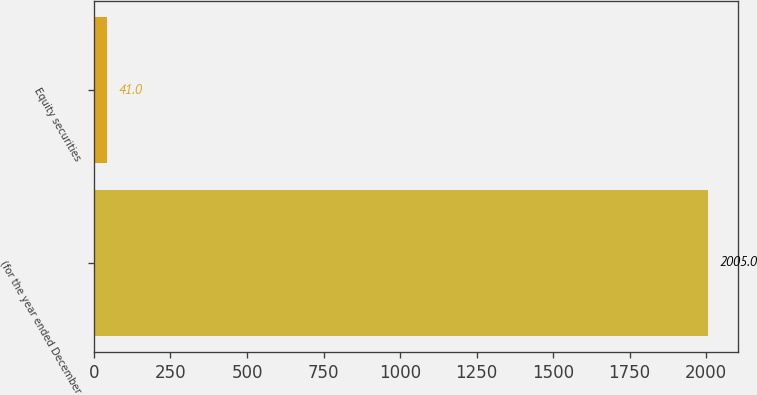Convert chart. <chart><loc_0><loc_0><loc_500><loc_500><bar_chart><fcel>(for the year ended December<fcel>Equity securities<nl><fcel>2005<fcel>41<nl></chart> 